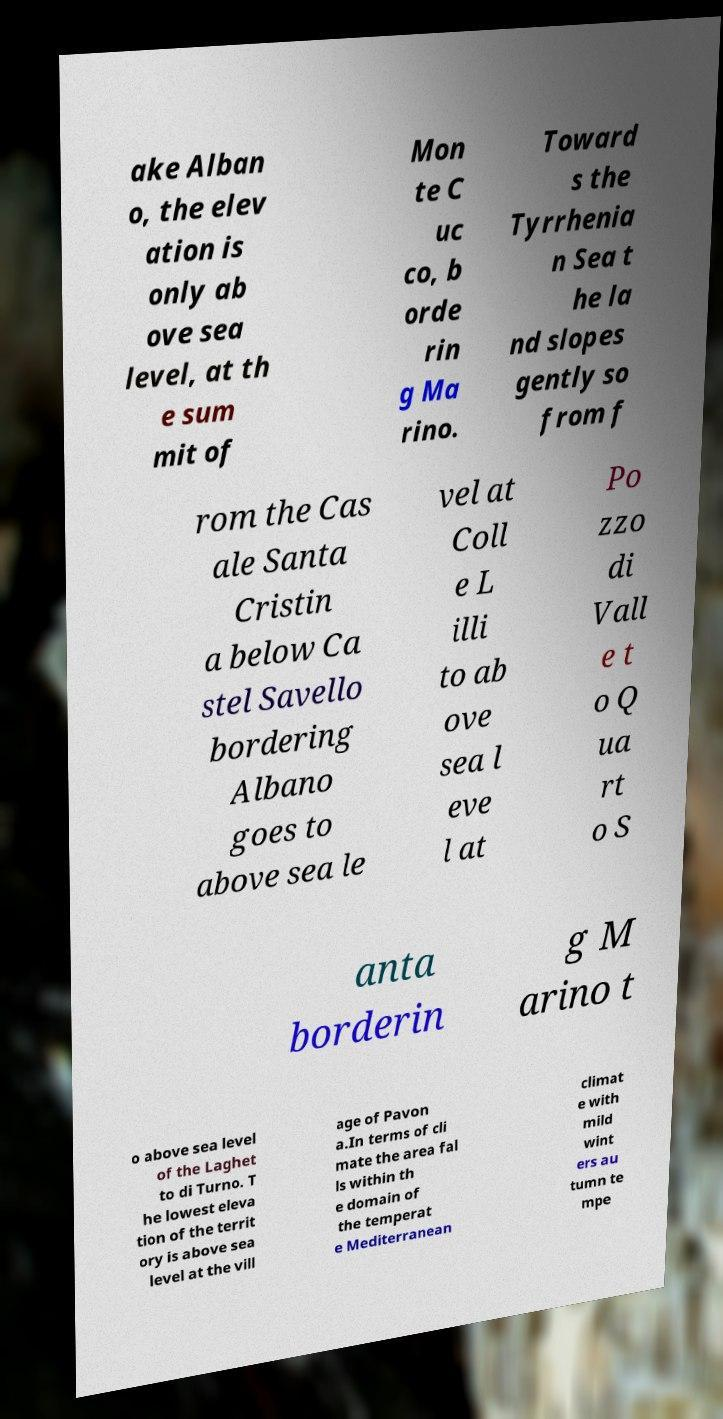There's text embedded in this image that I need extracted. Can you transcribe it verbatim? ake Alban o, the elev ation is only ab ove sea level, at th e sum mit of Mon te C uc co, b orde rin g Ma rino. Toward s the Tyrrhenia n Sea t he la nd slopes gently so from f rom the Cas ale Santa Cristin a below Ca stel Savello bordering Albano goes to above sea le vel at Coll e L illi to ab ove sea l eve l at Po zzo di Vall e t o Q ua rt o S anta borderin g M arino t o above sea level of the Laghet to di Turno. T he lowest eleva tion of the territ ory is above sea level at the vill age of Pavon a.In terms of cli mate the area fal ls within th e domain of the temperat e Mediterranean climat e with mild wint ers au tumn te mpe 